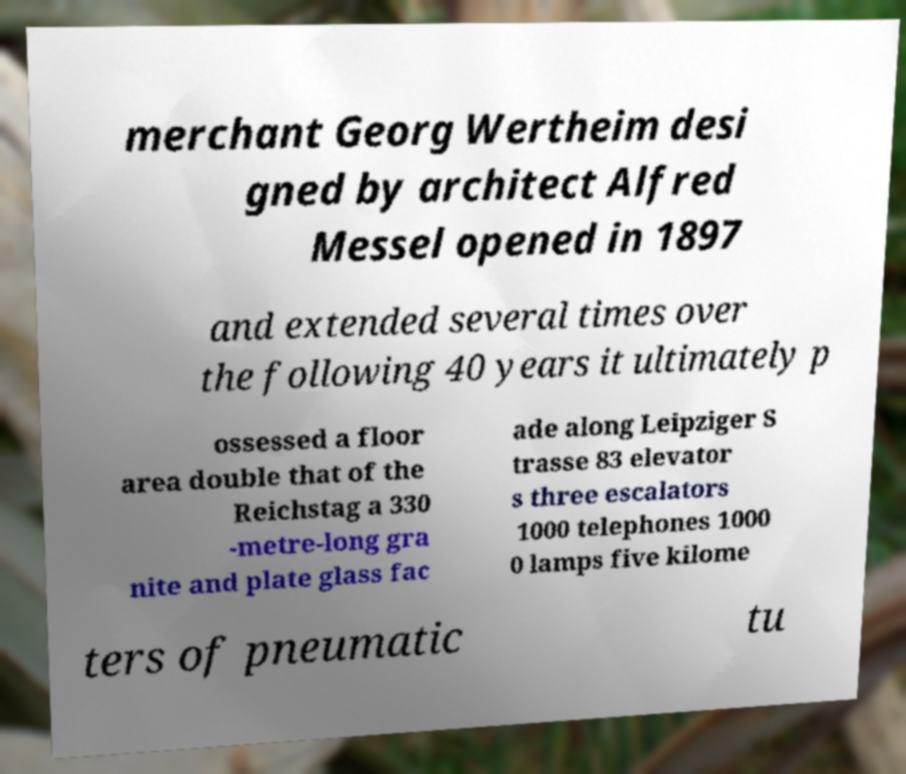Could you assist in decoding the text presented in this image and type it out clearly? merchant Georg Wertheim desi gned by architect Alfred Messel opened in 1897 and extended several times over the following 40 years it ultimately p ossessed a floor area double that of the Reichstag a 330 -metre-long gra nite and plate glass fac ade along Leipziger S trasse 83 elevator s three escalators 1000 telephones 1000 0 lamps five kilome ters of pneumatic tu 